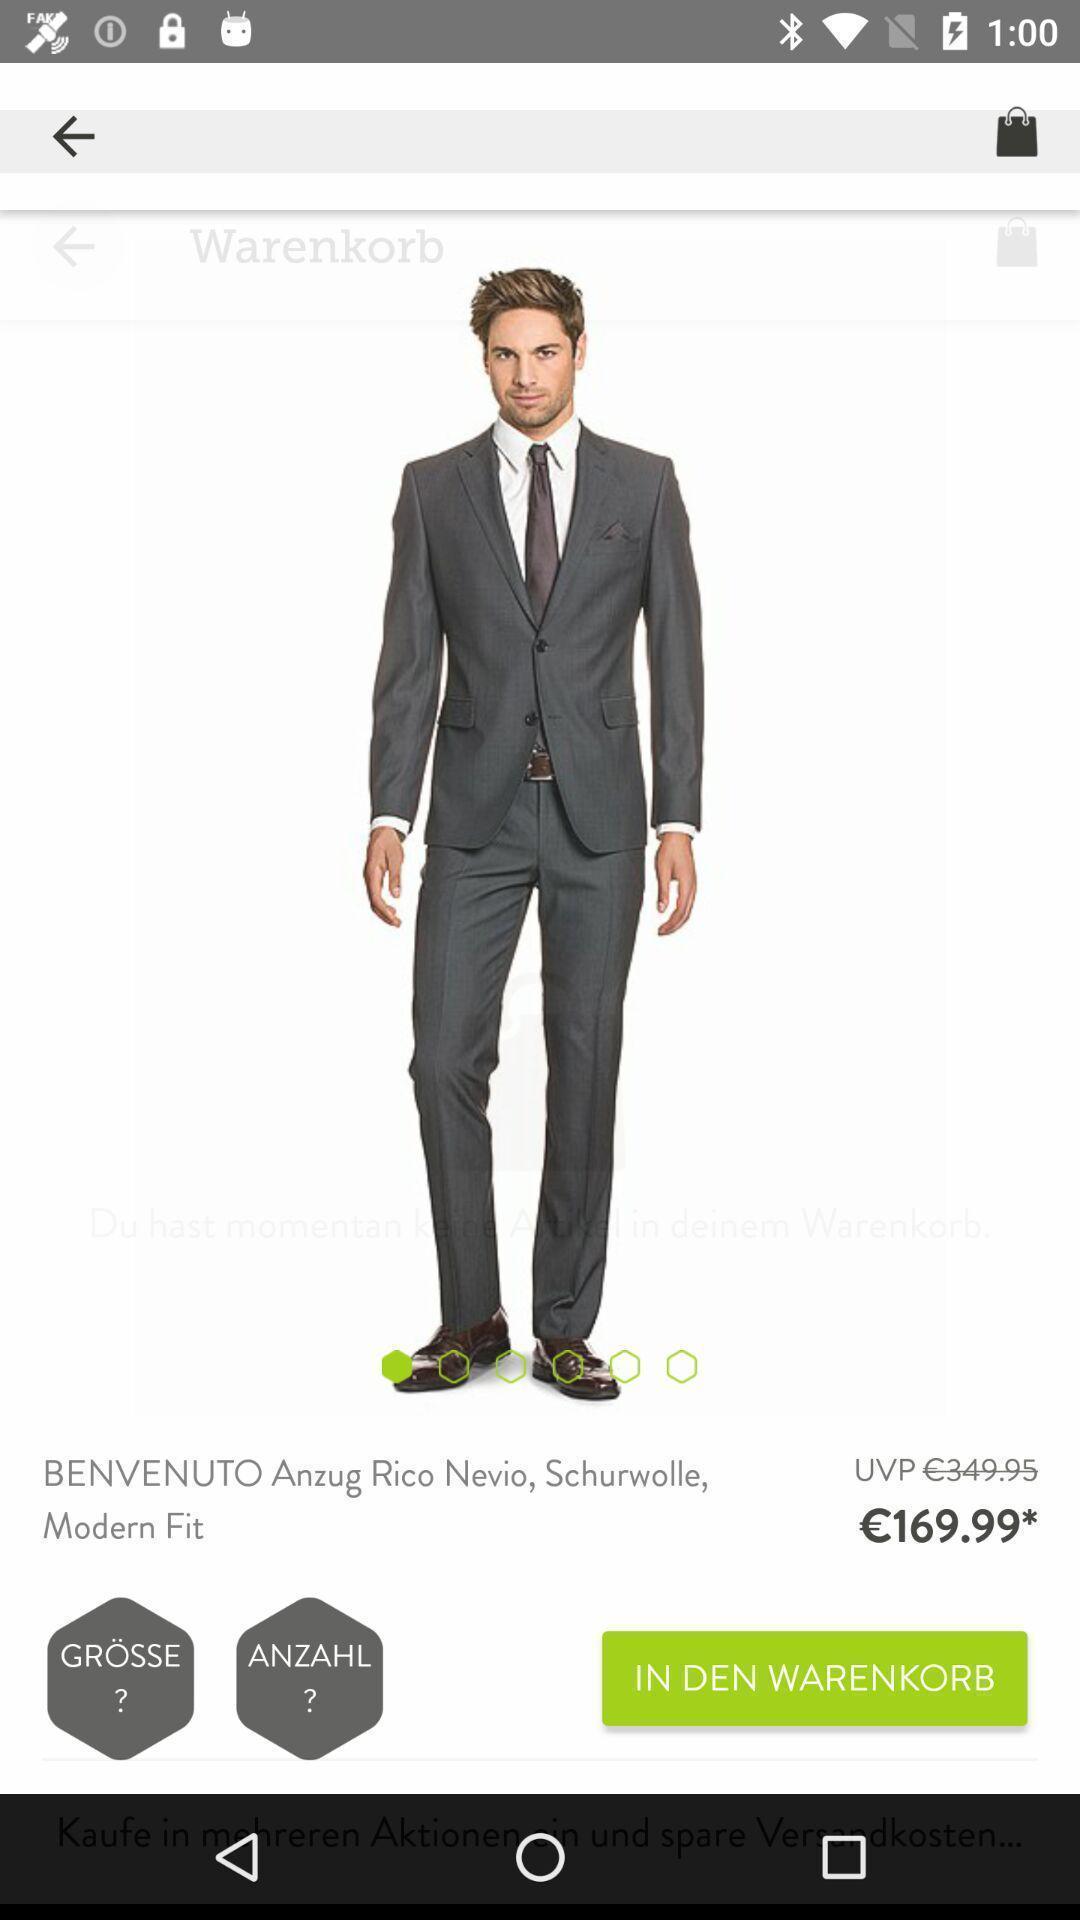What is the overall content of this screenshot? Screen displaying the product with price. 